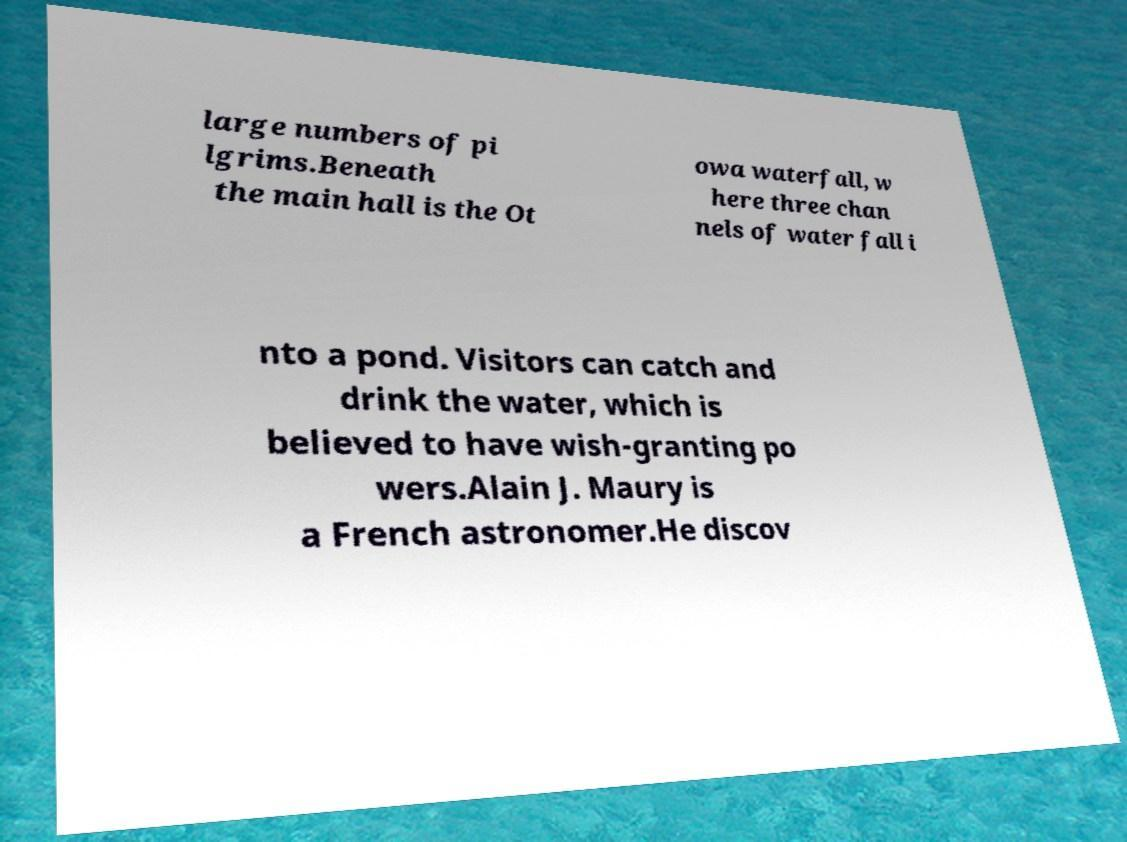There's text embedded in this image that I need extracted. Can you transcribe it verbatim? large numbers of pi lgrims.Beneath the main hall is the Ot owa waterfall, w here three chan nels of water fall i nto a pond. Visitors can catch and drink the water, which is believed to have wish-granting po wers.Alain J. Maury is a French astronomer.He discov 